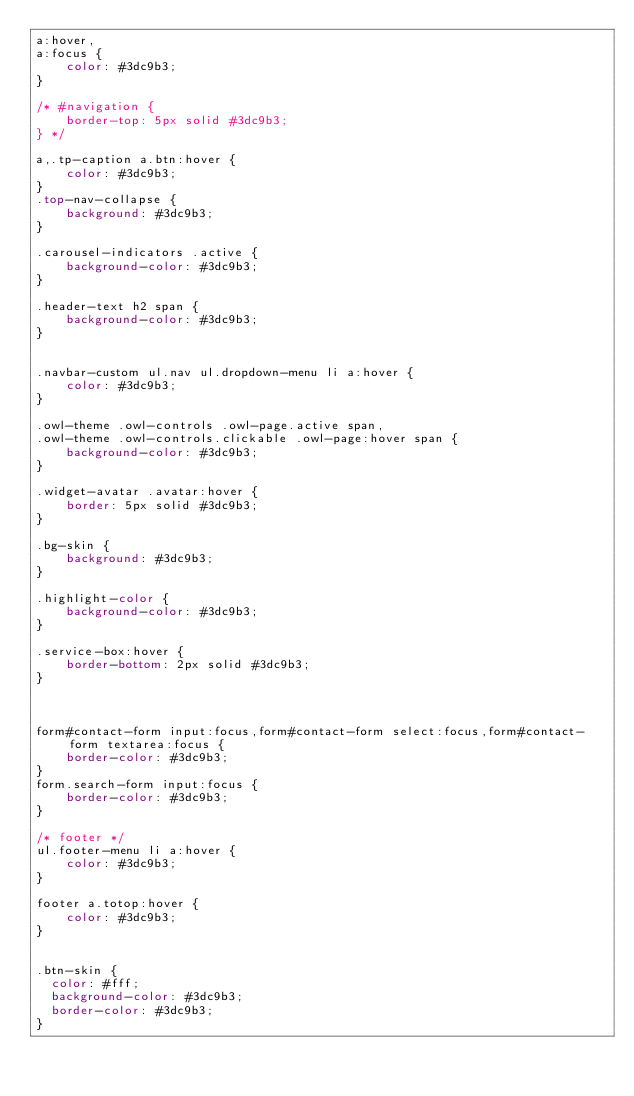<code> <loc_0><loc_0><loc_500><loc_500><_CSS_>a:hover,
a:focus {
    color: #3dc9b3;
}

/* #navigation {
	border-top: 5px solid #3dc9b3;
} */

a,.tp-caption a.btn:hover {
	color: #3dc9b3;
}
.top-nav-collapse {
	background: #3dc9b3;
}

.carousel-indicators .active {
    background-color: #3dc9b3;
}

.header-text h2 span {
    background-color: #3dc9b3;
}


.navbar-custom ul.nav ul.dropdown-menu li a:hover {
	color: #3dc9b3;
}

.owl-theme .owl-controls .owl-page.active span,
.owl-theme .owl-controls.clickable .owl-page:hover span {
    background-color: #3dc9b3;
}

.widget-avatar .avatar:hover {
    border: 5px solid #3dc9b3;
}

.bg-skin {
	background: #3dc9b3;
}

.highlight-color {
	background-color: #3dc9b3;
}

.service-box:hover {
	border-bottom: 2px solid #3dc9b3;
}



form#contact-form input:focus,form#contact-form select:focus,form#contact-form textarea:focus {
	border-color: #3dc9b3;
}
form.search-form input:focus {
	border-color: #3dc9b3;
}

/* footer */
ul.footer-menu li a:hover {
	color: #3dc9b3;
}

footer a.totop:hover {
	color: #3dc9b3;
}


.btn-skin {
  color: #fff;
  background-color: #3dc9b3;
  border-color: #3dc9b3;
}
</code> 